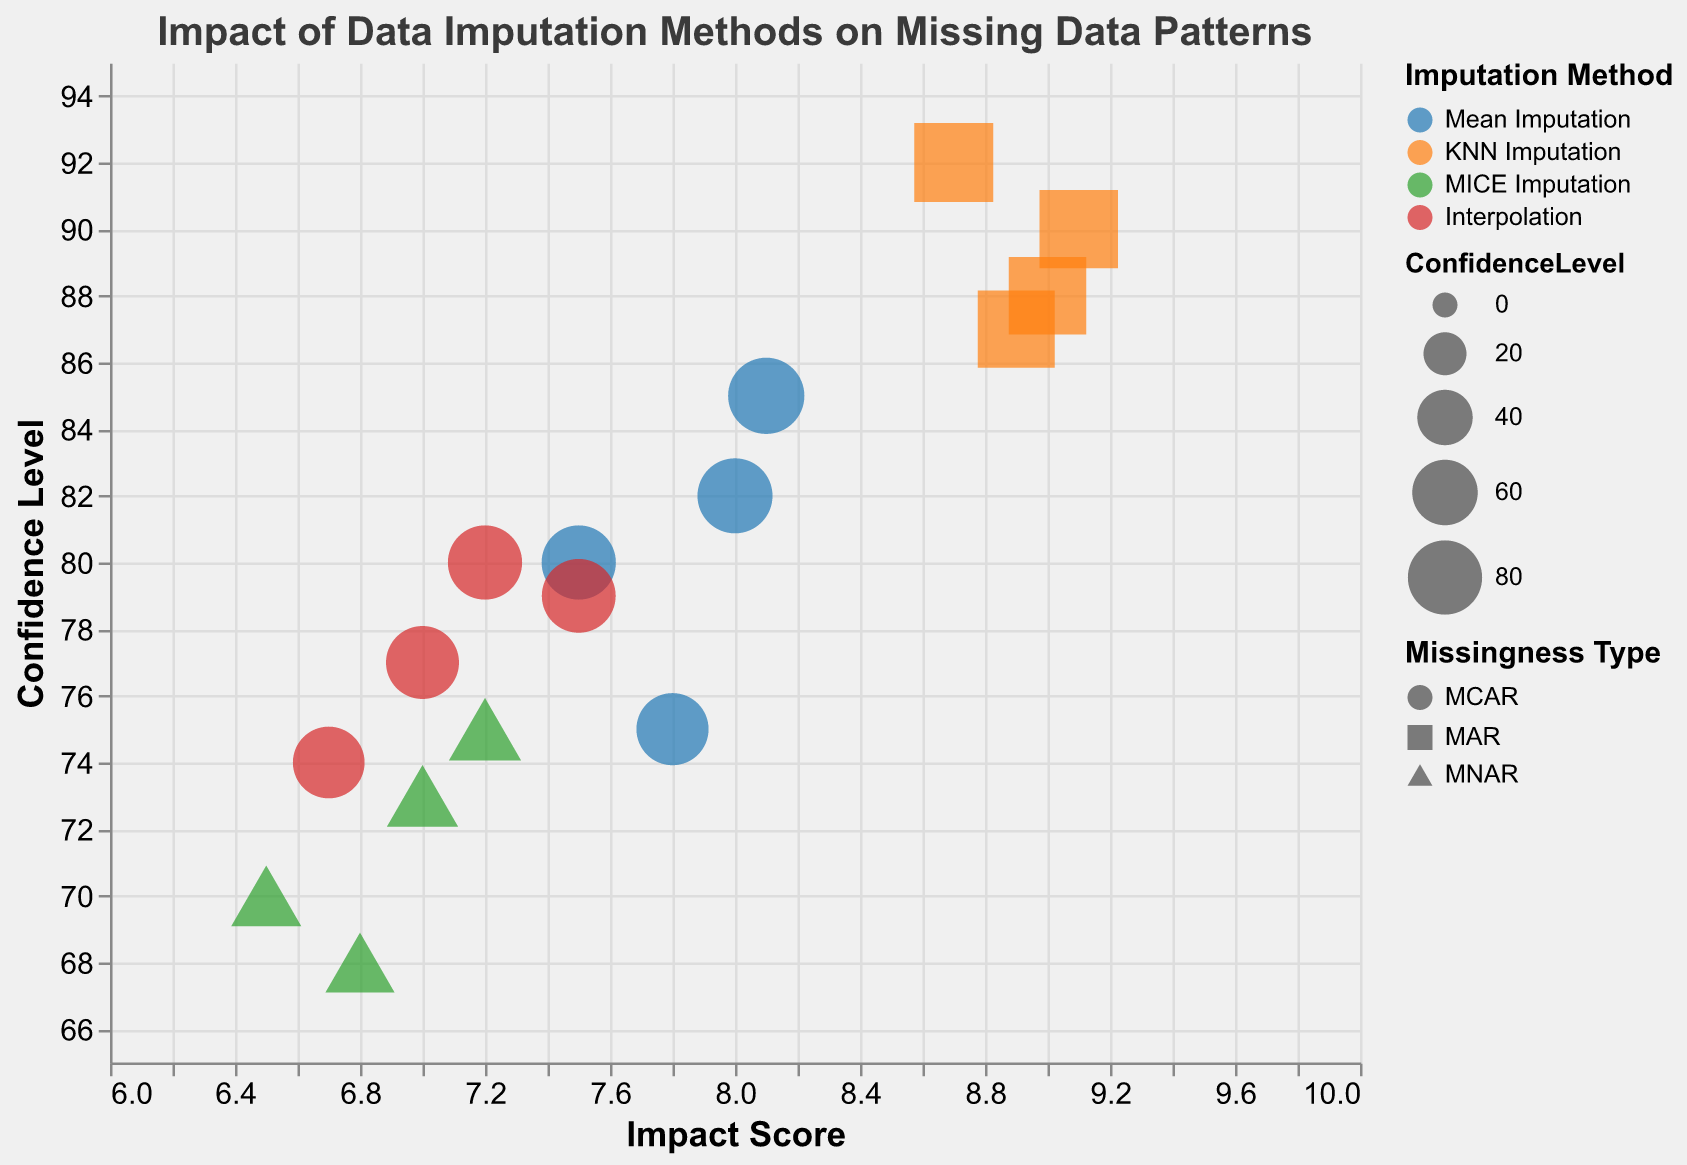What is the title of the figure? The title is generally placed at the top of the figure. In this figure, it is clearly written.
Answer: Impact of Data Imputation Methods on Missing Data Patterns What does the x-axis represent? The x-axis represents the "Impact Score" as indicated by the axis title.
Answer: Impact Score How are the colors used in the figure? The colors represent different imputation methods as indicated in the legend. For instance, Mean Imputation is represented by blue, KNN Imputation by orange, MICE Imputation by green, and Interpolation by red.
Answer: They represent different imputation methods What shape is used for the MAR missingness type? The legend indicates the shape for each missingness type. For MAR, a square shape is used.
Answer: Square Which imputation method has the highest impact score for the age range 0-18? By following the bubbles corresponding to the age range 0-18 and looking for the highest Impact Score, KNN Imputation is found to have an impact score of 9.0.
Answer: KNN Imputation What is the average confidence level for the KNN Imputation method across all age ranges? The confidence levels for KNN Imputation are 88, 92, 90, and 87. Summing these up gives 357. There are 4 age ranges, so the average is 357/4 = 89.25
Answer: 89.25 Compare the impact score of Mean Imputation and Interpolation methods for the age range 65+. Which method has a higher impact score? By checking the impact scores for the age range 65+, Mean Imputation has a score of 8.0, and Interpolation has a score of 7.5. Therefore, Mean Imputation has a higher impact score.
Answer: Mean Imputation How does the impact score of KNN Imputation for the age range 19-40 compare to the impact score of MICE Imputation for the same age range? The impact score for KNN Imputation for the age range 19-40 is 8.7, and for MICE Imputation, it is 7.0. Therefore, KNN Imputation has a higher impact score.
Answer: KNN Imputation has a higher impact score Which missingness type has the lowest confidence level within the age range 41-64? The impact scores for the age range 41-64 are segmented based on shapes. By identifying the lowest confidence level, the MICE Imputation with MNAR at 68 is the lowest.
Answer: MNAR What is the largest bubble size on the chart and which data point does it correspond to? The size of the bubble corresponds to the confidence level. The largest size on the chart corresponds to the highest confidence level. Here, it is a confidence level of 92 for KNN Imputation in the age range 19-40.
Answer: Confidence level of 92 for KNN Imputation in 19-40 age range 